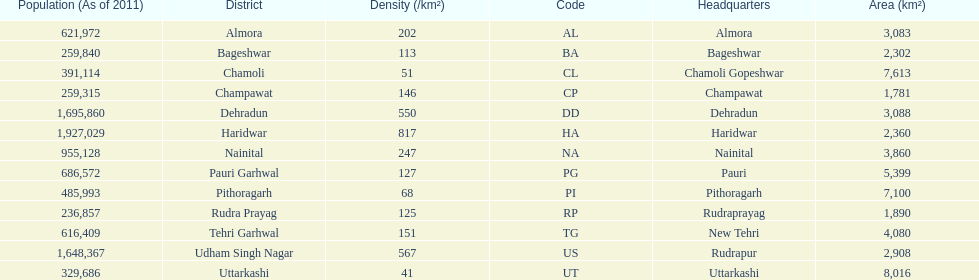What are the names of all the districts? Almora, Bageshwar, Chamoli, Champawat, Dehradun, Haridwar, Nainital, Pauri Garhwal, Pithoragarh, Rudra Prayag, Tehri Garhwal, Udham Singh Nagar, Uttarkashi. What range of densities do these districts encompass? 202, 113, 51, 146, 550, 817, 247, 127, 68, 125, 151, 567, 41. Which district has a density of 51? Chamoli. 